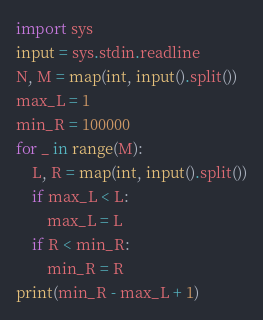Convert code to text. <code><loc_0><loc_0><loc_500><loc_500><_Python_>import sys
input = sys.stdin.readline
N, M = map(int, input().split())
max_L = 1
min_R = 100000
for _ in range(M):
	L, R = map(int, input().split())
	if max_L < L:
		max_L = L
	if R < min_R:
		min_R = R
print(min_R - max_L + 1)</code> 